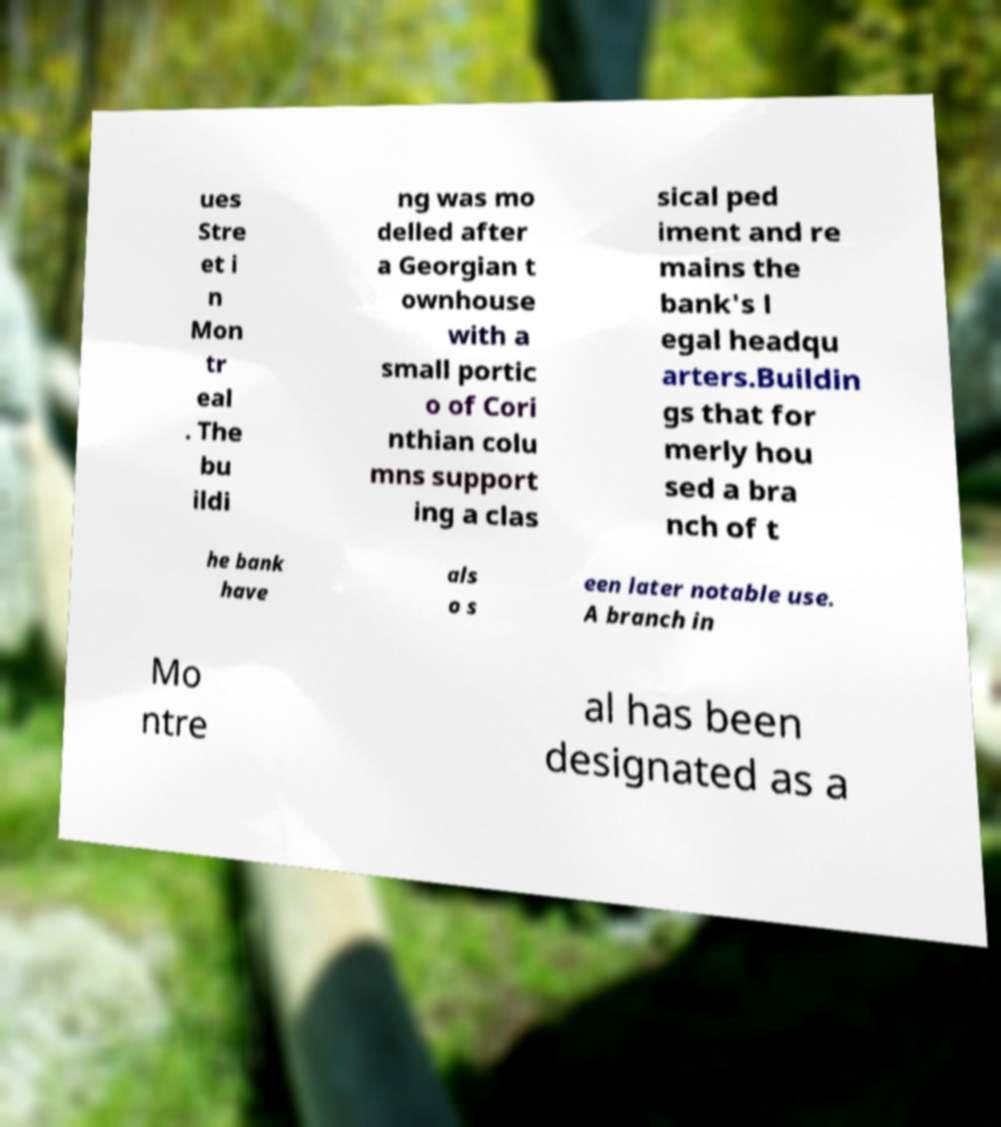Please read and relay the text visible in this image. What does it say? ues Stre et i n Mon tr eal . The bu ildi ng was mo delled after a Georgian t ownhouse with a small portic o of Cori nthian colu mns support ing a clas sical ped iment and re mains the bank's l egal headqu arters.Buildin gs that for merly hou sed a bra nch of t he bank have als o s een later notable use. A branch in Mo ntre al has been designated as a 